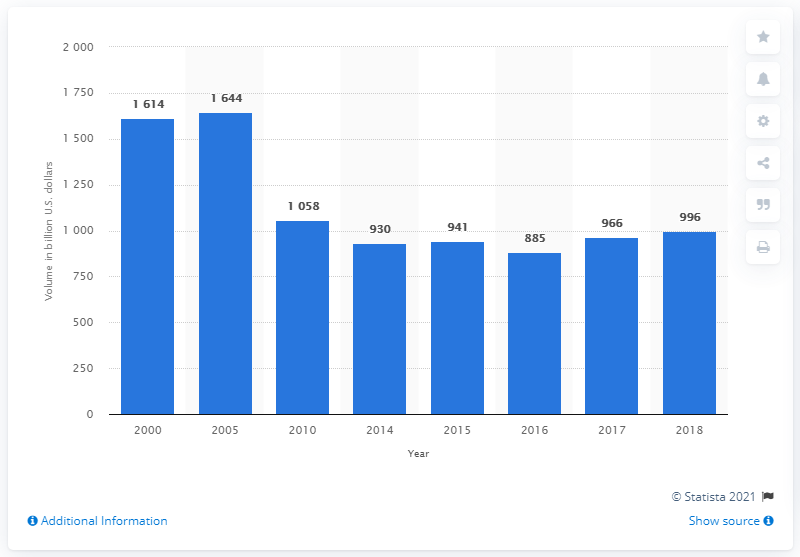What trend does the chart show for money market instruments from 2000 to 2018? The chart illustrates an overall growth trend in the volume of money market instruments outstanding in the U.S. from 2000 to 2018, with a peak around 2005 followed by a decline and subsequent stabilization around the 900-1000 billion dollar range from 2010 onward. 